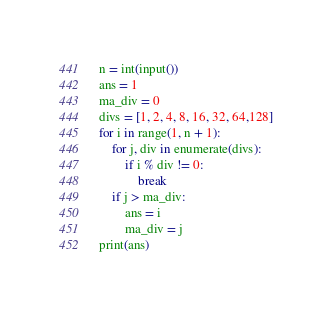Convert code to text. <code><loc_0><loc_0><loc_500><loc_500><_Python_>n = int(input())
ans = 1
ma_div = 0
divs = [1, 2, 4, 8, 16, 32, 64,128]
for i in range(1, n + 1):
    for j, div in enumerate(divs):
        if i % div != 0:
            break
    if j > ma_div:
        ans = i
        ma_div = j
print(ans)
</code> 